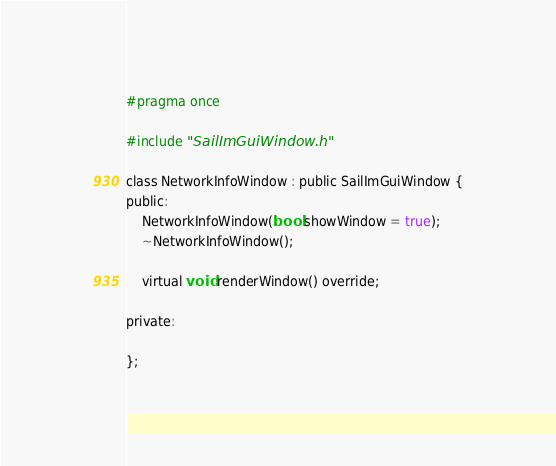<code> <loc_0><loc_0><loc_500><loc_500><_C_>#pragma once

#include "SailImGuiWindow.h"

class NetworkInfoWindow : public SailImGuiWindow {
public:
	NetworkInfoWindow(bool showWindow = true);
	~NetworkInfoWindow();

	virtual void renderWindow() override;

private:

};</code> 